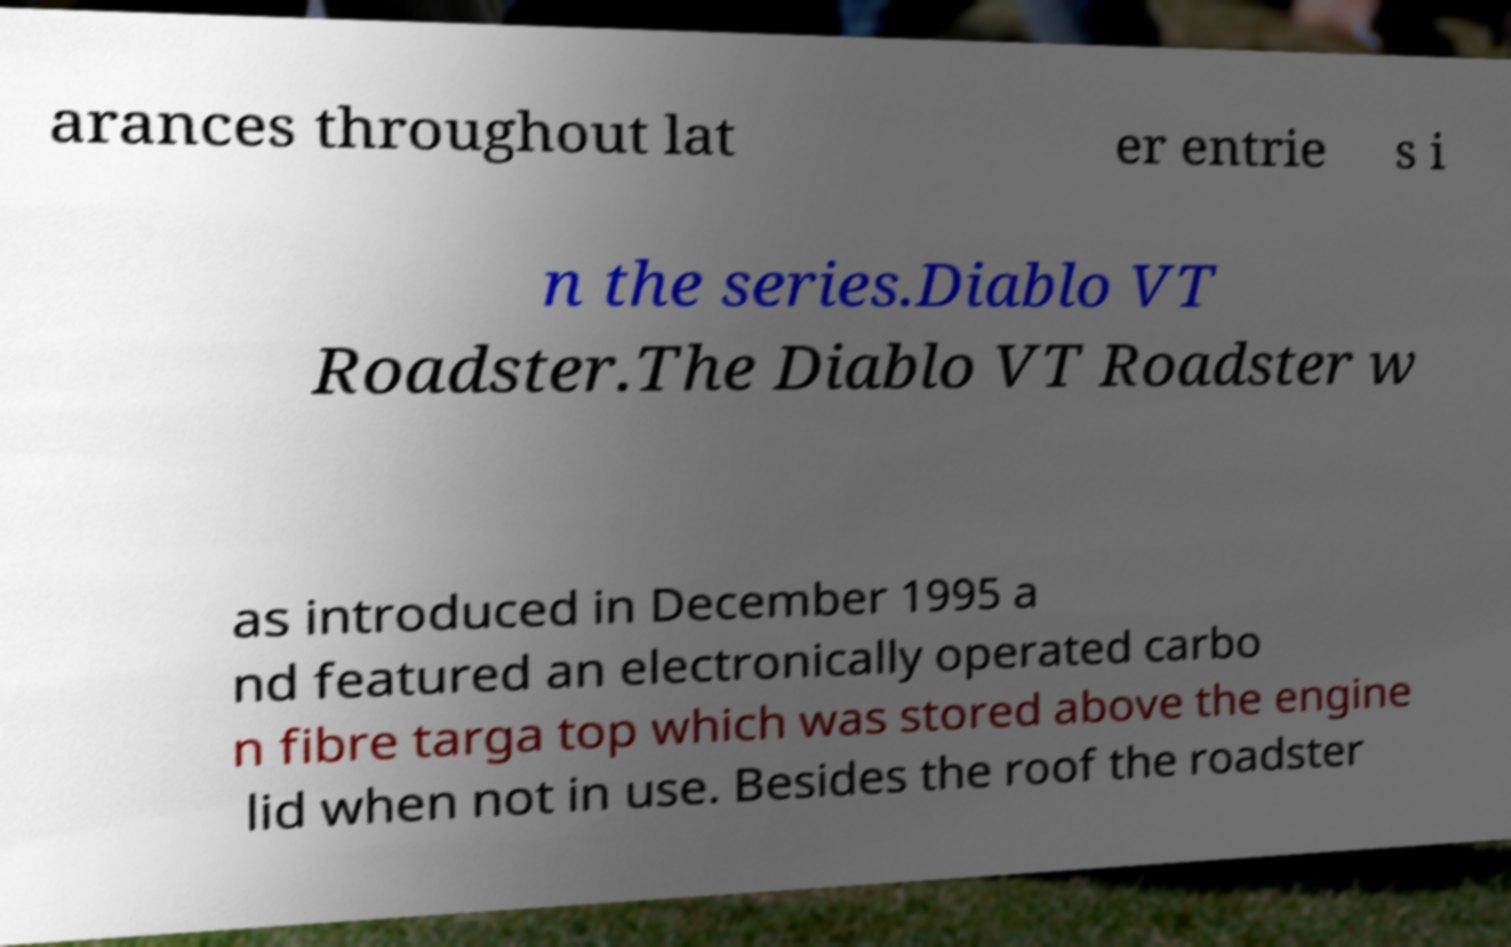There's text embedded in this image that I need extracted. Can you transcribe it verbatim? arances throughout lat er entrie s i n the series.Diablo VT Roadster.The Diablo VT Roadster w as introduced in December 1995 a nd featured an electronically operated carbo n fibre targa top which was stored above the engine lid when not in use. Besides the roof the roadster 